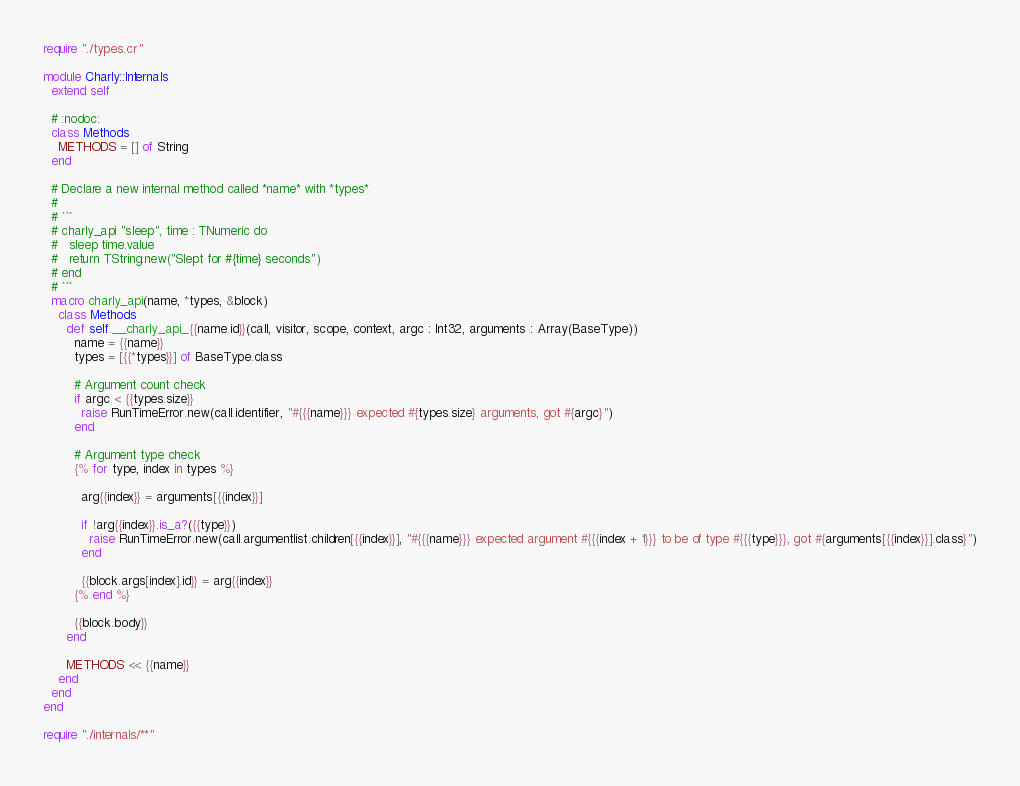Convert code to text. <code><loc_0><loc_0><loc_500><loc_500><_Crystal_>require "./types.cr"

module Charly::Internals
  extend self

  # :nodoc:
  class Methods
    METHODS = [] of String
  end

  # Declare a new internal method called *name* with *types*
  #
  # ```
  # charly_api "sleep", time : TNumeric do
  #   sleep time.value
  #   return TString.new("Slept for #{time} seconds")
  # end
  # ```
  macro charly_api(name, *types, &block)
    class Methods
      def self.__charly_api_{{name.id}}(call, visitor, scope, context, argc : Int32, arguments : Array(BaseType))
        name = {{name}}
        types = [{{*types}}] of BaseType.class

        # Argument count check
        if argc < {{types.size}}
          raise RunTimeError.new(call.identifier, "#{{{name}}} expected #{types.size} arguments, got #{argc}")
        end

        # Argument type check
        {% for type, index in types %}

          arg{{index}} = arguments[{{index}}]

          if !arg{{index}}.is_a?({{type}})
            raise RunTimeError.new(call.argumentlist.children[{{index}}], "#{{{name}}} expected argument #{{{index + 1}}} to be of type #{{{type}}}, got #{arguments[{{index}}].class}")
          end

          {{block.args[index].id}} = arg{{index}}
        {% end %}

        {{block.body}}
      end

      METHODS << {{name}}
    end
  end
end

require "./internals/**"
</code> 